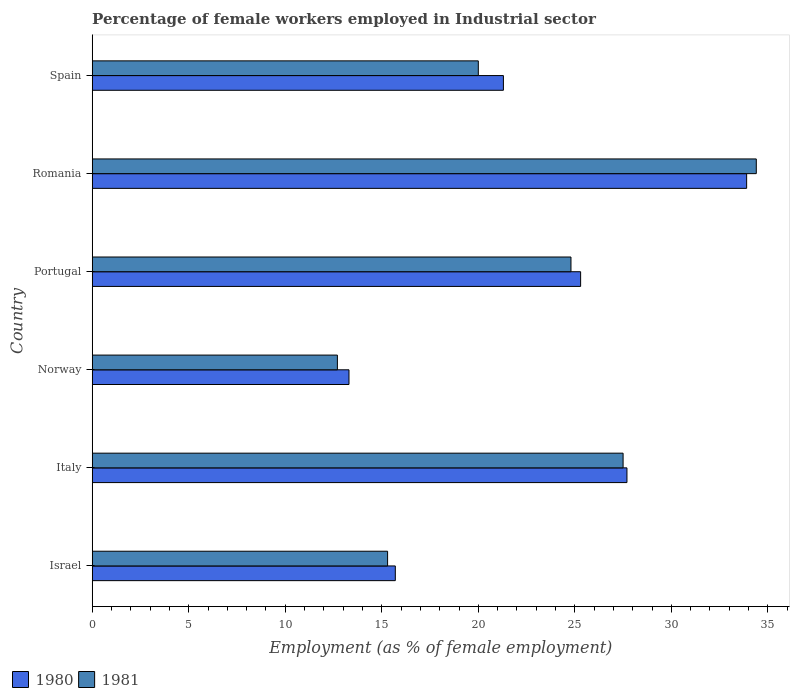How many groups of bars are there?
Offer a very short reply. 6. Are the number of bars per tick equal to the number of legend labels?
Give a very brief answer. Yes. How many bars are there on the 3rd tick from the top?
Your answer should be compact. 2. How many bars are there on the 6th tick from the bottom?
Offer a terse response. 2. What is the label of the 2nd group of bars from the top?
Keep it short and to the point. Romania. What is the percentage of females employed in Industrial sector in 1981 in Portugal?
Keep it short and to the point. 24.8. Across all countries, what is the maximum percentage of females employed in Industrial sector in 1981?
Offer a very short reply. 34.4. Across all countries, what is the minimum percentage of females employed in Industrial sector in 1981?
Provide a succinct answer. 12.7. In which country was the percentage of females employed in Industrial sector in 1981 maximum?
Make the answer very short. Romania. What is the total percentage of females employed in Industrial sector in 1981 in the graph?
Keep it short and to the point. 134.7. What is the difference between the percentage of females employed in Industrial sector in 1980 in Norway and that in Spain?
Provide a short and direct response. -8. What is the difference between the percentage of females employed in Industrial sector in 1980 in Spain and the percentage of females employed in Industrial sector in 1981 in Romania?
Ensure brevity in your answer.  -13.1. What is the average percentage of females employed in Industrial sector in 1980 per country?
Make the answer very short. 22.87. What is the difference between the percentage of females employed in Industrial sector in 1981 and percentage of females employed in Industrial sector in 1980 in Italy?
Offer a very short reply. -0.2. In how many countries, is the percentage of females employed in Industrial sector in 1980 greater than 24 %?
Keep it short and to the point. 3. What is the ratio of the percentage of females employed in Industrial sector in 1980 in Israel to that in Italy?
Keep it short and to the point. 0.57. Is the difference between the percentage of females employed in Industrial sector in 1981 in Italy and Romania greater than the difference between the percentage of females employed in Industrial sector in 1980 in Italy and Romania?
Your response must be concise. No. What is the difference between the highest and the second highest percentage of females employed in Industrial sector in 1981?
Make the answer very short. 6.9. What is the difference between the highest and the lowest percentage of females employed in Industrial sector in 1980?
Your response must be concise. 20.6. In how many countries, is the percentage of females employed in Industrial sector in 1981 greater than the average percentage of females employed in Industrial sector in 1981 taken over all countries?
Provide a succinct answer. 3. Is the sum of the percentage of females employed in Industrial sector in 1980 in Italy and Spain greater than the maximum percentage of females employed in Industrial sector in 1981 across all countries?
Keep it short and to the point. Yes. What does the 2nd bar from the bottom in Portugal represents?
Give a very brief answer. 1981. What is the difference between two consecutive major ticks on the X-axis?
Make the answer very short. 5. Are the values on the major ticks of X-axis written in scientific E-notation?
Your answer should be compact. No. Does the graph contain grids?
Provide a succinct answer. No. What is the title of the graph?
Keep it short and to the point. Percentage of female workers employed in Industrial sector. Does "2011" appear as one of the legend labels in the graph?
Offer a very short reply. No. What is the label or title of the X-axis?
Your response must be concise. Employment (as % of female employment). What is the Employment (as % of female employment) of 1980 in Israel?
Give a very brief answer. 15.7. What is the Employment (as % of female employment) of 1981 in Israel?
Give a very brief answer. 15.3. What is the Employment (as % of female employment) of 1980 in Italy?
Give a very brief answer. 27.7. What is the Employment (as % of female employment) of 1980 in Norway?
Ensure brevity in your answer.  13.3. What is the Employment (as % of female employment) in 1981 in Norway?
Your answer should be very brief. 12.7. What is the Employment (as % of female employment) in 1980 in Portugal?
Offer a terse response. 25.3. What is the Employment (as % of female employment) in 1981 in Portugal?
Keep it short and to the point. 24.8. What is the Employment (as % of female employment) in 1980 in Romania?
Provide a short and direct response. 33.9. What is the Employment (as % of female employment) of 1981 in Romania?
Offer a very short reply. 34.4. What is the Employment (as % of female employment) in 1980 in Spain?
Offer a very short reply. 21.3. Across all countries, what is the maximum Employment (as % of female employment) in 1980?
Ensure brevity in your answer.  33.9. Across all countries, what is the maximum Employment (as % of female employment) in 1981?
Your answer should be compact. 34.4. Across all countries, what is the minimum Employment (as % of female employment) in 1980?
Offer a very short reply. 13.3. Across all countries, what is the minimum Employment (as % of female employment) in 1981?
Your response must be concise. 12.7. What is the total Employment (as % of female employment) in 1980 in the graph?
Your answer should be very brief. 137.2. What is the total Employment (as % of female employment) in 1981 in the graph?
Make the answer very short. 134.7. What is the difference between the Employment (as % of female employment) of 1981 in Israel and that in Italy?
Provide a succinct answer. -12.2. What is the difference between the Employment (as % of female employment) in 1981 in Israel and that in Norway?
Your answer should be very brief. 2.6. What is the difference between the Employment (as % of female employment) in 1980 in Israel and that in Portugal?
Ensure brevity in your answer.  -9.6. What is the difference between the Employment (as % of female employment) in 1981 in Israel and that in Portugal?
Your response must be concise. -9.5. What is the difference between the Employment (as % of female employment) in 1980 in Israel and that in Romania?
Keep it short and to the point. -18.2. What is the difference between the Employment (as % of female employment) of 1981 in Israel and that in Romania?
Your answer should be compact. -19.1. What is the difference between the Employment (as % of female employment) of 1980 in Italy and that in Norway?
Provide a succinct answer. 14.4. What is the difference between the Employment (as % of female employment) of 1980 in Italy and that in Romania?
Offer a very short reply. -6.2. What is the difference between the Employment (as % of female employment) of 1980 in Norway and that in Portugal?
Your answer should be very brief. -12. What is the difference between the Employment (as % of female employment) of 1981 in Norway and that in Portugal?
Your response must be concise. -12.1. What is the difference between the Employment (as % of female employment) in 1980 in Norway and that in Romania?
Offer a very short reply. -20.6. What is the difference between the Employment (as % of female employment) of 1981 in Norway and that in Romania?
Keep it short and to the point. -21.7. What is the difference between the Employment (as % of female employment) in 1981 in Norway and that in Spain?
Offer a very short reply. -7.3. What is the difference between the Employment (as % of female employment) of 1980 in Portugal and that in Romania?
Offer a terse response. -8.6. What is the difference between the Employment (as % of female employment) in 1981 in Portugal and that in Romania?
Provide a short and direct response. -9.6. What is the difference between the Employment (as % of female employment) of 1980 in Portugal and that in Spain?
Ensure brevity in your answer.  4. What is the difference between the Employment (as % of female employment) of 1981 in Portugal and that in Spain?
Make the answer very short. 4.8. What is the difference between the Employment (as % of female employment) in 1980 in Israel and the Employment (as % of female employment) in 1981 in Norway?
Your answer should be compact. 3. What is the difference between the Employment (as % of female employment) of 1980 in Israel and the Employment (as % of female employment) of 1981 in Portugal?
Your answer should be compact. -9.1. What is the difference between the Employment (as % of female employment) in 1980 in Israel and the Employment (as % of female employment) in 1981 in Romania?
Give a very brief answer. -18.7. What is the difference between the Employment (as % of female employment) in 1980 in Israel and the Employment (as % of female employment) in 1981 in Spain?
Give a very brief answer. -4.3. What is the difference between the Employment (as % of female employment) of 1980 in Italy and the Employment (as % of female employment) of 1981 in Norway?
Offer a very short reply. 15. What is the difference between the Employment (as % of female employment) of 1980 in Italy and the Employment (as % of female employment) of 1981 in Portugal?
Your answer should be very brief. 2.9. What is the difference between the Employment (as % of female employment) of 1980 in Italy and the Employment (as % of female employment) of 1981 in Romania?
Make the answer very short. -6.7. What is the difference between the Employment (as % of female employment) of 1980 in Italy and the Employment (as % of female employment) of 1981 in Spain?
Make the answer very short. 7.7. What is the difference between the Employment (as % of female employment) in 1980 in Norway and the Employment (as % of female employment) in 1981 in Romania?
Provide a short and direct response. -21.1. What is the difference between the Employment (as % of female employment) in 1980 in Norway and the Employment (as % of female employment) in 1981 in Spain?
Provide a succinct answer. -6.7. What is the difference between the Employment (as % of female employment) in 1980 in Portugal and the Employment (as % of female employment) in 1981 in Spain?
Make the answer very short. 5.3. What is the difference between the Employment (as % of female employment) in 1980 in Romania and the Employment (as % of female employment) in 1981 in Spain?
Offer a very short reply. 13.9. What is the average Employment (as % of female employment) in 1980 per country?
Give a very brief answer. 22.87. What is the average Employment (as % of female employment) in 1981 per country?
Ensure brevity in your answer.  22.45. What is the difference between the Employment (as % of female employment) in 1980 and Employment (as % of female employment) in 1981 in Portugal?
Keep it short and to the point. 0.5. What is the difference between the Employment (as % of female employment) in 1980 and Employment (as % of female employment) in 1981 in Romania?
Provide a short and direct response. -0.5. What is the ratio of the Employment (as % of female employment) in 1980 in Israel to that in Italy?
Give a very brief answer. 0.57. What is the ratio of the Employment (as % of female employment) of 1981 in Israel to that in Italy?
Your response must be concise. 0.56. What is the ratio of the Employment (as % of female employment) in 1980 in Israel to that in Norway?
Make the answer very short. 1.18. What is the ratio of the Employment (as % of female employment) in 1981 in Israel to that in Norway?
Make the answer very short. 1.2. What is the ratio of the Employment (as % of female employment) in 1980 in Israel to that in Portugal?
Your answer should be compact. 0.62. What is the ratio of the Employment (as % of female employment) in 1981 in Israel to that in Portugal?
Provide a short and direct response. 0.62. What is the ratio of the Employment (as % of female employment) of 1980 in Israel to that in Romania?
Provide a succinct answer. 0.46. What is the ratio of the Employment (as % of female employment) in 1981 in Israel to that in Romania?
Ensure brevity in your answer.  0.44. What is the ratio of the Employment (as % of female employment) in 1980 in Israel to that in Spain?
Ensure brevity in your answer.  0.74. What is the ratio of the Employment (as % of female employment) in 1981 in Israel to that in Spain?
Ensure brevity in your answer.  0.77. What is the ratio of the Employment (as % of female employment) in 1980 in Italy to that in Norway?
Your answer should be compact. 2.08. What is the ratio of the Employment (as % of female employment) of 1981 in Italy to that in Norway?
Provide a short and direct response. 2.17. What is the ratio of the Employment (as % of female employment) in 1980 in Italy to that in Portugal?
Keep it short and to the point. 1.09. What is the ratio of the Employment (as % of female employment) of 1981 in Italy to that in Portugal?
Your answer should be very brief. 1.11. What is the ratio of the Employment (as % of female employment) of 1980 in Italy to that in Romania?
Provide a short and direct response. 0.82. What is the ratio of the Employment (as % of female employment) of 1981 in Italy to that in Romania?
Your response must be concise. 0.8. What is the ratio of the Employment (as % of female employment) in 1980 in Italy to that in Spain?
Your answer should be very brief. 1.3. What is the ratio of the Employment (as % of female employment) of 1981 in Italy to that in Spain?
Provide a short and direct response. 1.38. What is the ratio of the Employment (as % of female employment) in 1980 in Norway to that in Portugal?
Offer a very short reply. 0.53. What is the ratio of the Employment (as % of female employment) in 1981 in Norway to that in Portugal?
Your answer should be very brief. 0.51. What is the ratio of the Employment (as % of female employment) in 1980 in Norway to that in Romania?
Provide a succinct answer. 0.39. What is the ratio of the Employment (as % of female employment) of 1981 in Norway to that in Romania?
Keep it short and to the point. 0.37. What is the ratio of the Employment (as % of female employment) in 1980 in Norway to that in Spain?
Your response must be concise. 0.62. What is the ratio of the Employment (as % of female employment) of 1981 in Norway to that in Spain?
Provide a short and direct response. 0.64. What is the ratio of the Employment (as % of female employment) of 1980 in Portugal to that in Romania?
Keep it short and to the point. 0.75. What is the ratio of the Employment (as % of female employment) of 1981 in Portugal to that in Romania?
Keep it short and to the point. 0.72. What is the ratio of the Employment (as % of female employment) of 1980 in Portugal to that in Spain?
Your answer should be very brief. 1.19. What is the ratio of the Employment (as % of female employment) of 1981 in Portugal to that in Spain?
Make the answer very short. 1.24. What is the ratio of the Employment (as % of female employment) in 1980 in Romania to that in Spain?
Provide a short and direct response. 1.59. What is the ratio of the Employment (as % of female employment) of 1981 in Romania to that in Spain?
Offer a very short reply. 1.72. What is the difference between the highest and the second highest Employment (as % of female employment) of 1980?
Your answer should be compact. 6.2. What is the difference between the highest and the lowest Employment (as % of female employment) in 1980?
Make the answer very short. 20.6. What is the difference between the highest and the lowest Employment (as % of female employment) in 1981?
Provide a short and direct response. 21.7. 